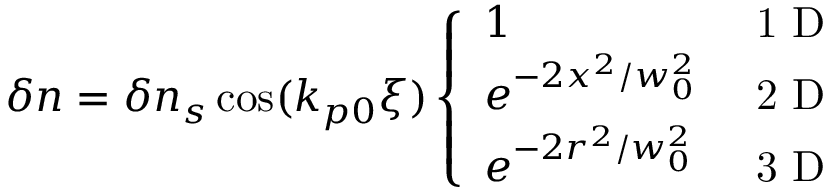<formula> <loc_0><loc_0><loc_500><loc_500>\begin{array} { r } { \delta n = \delta n _ { s } \cos ( k _ { p 0 } \xi ) \left \{ \begin{array} { l l } { 1 } & { 1 D } \\ { e ^ { - 2 x ^ { 2 } / w _ { 0 } ^ { 2 } } } & { 2 D } \\ { e ^ { - 2 r ^ { 2 } / w _ { 0 } ^ { 2 } } } & { 3 D } \end{array} } \end{array}</formula> 